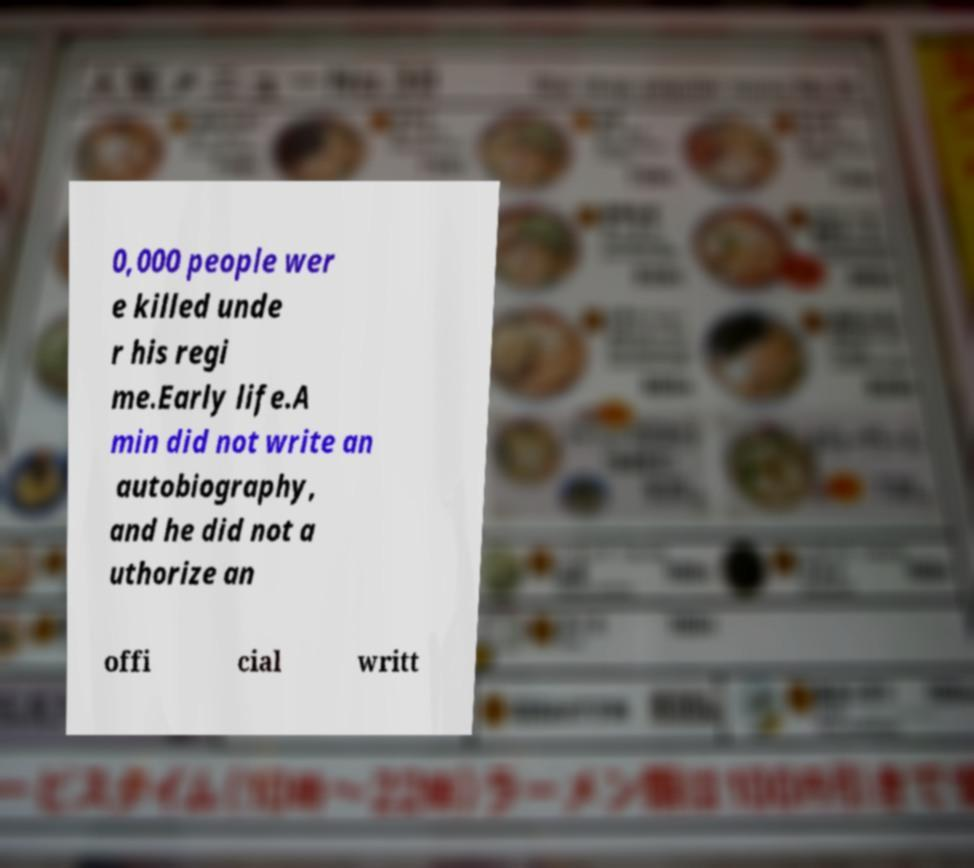There's text embedded in this image that I need extracted. Can you transcribe it verbatim? 0,000 people wer e killed unde r his regi me.Early life.A min did not write an autobiography, and he did not a uthorize an offi cial writt 